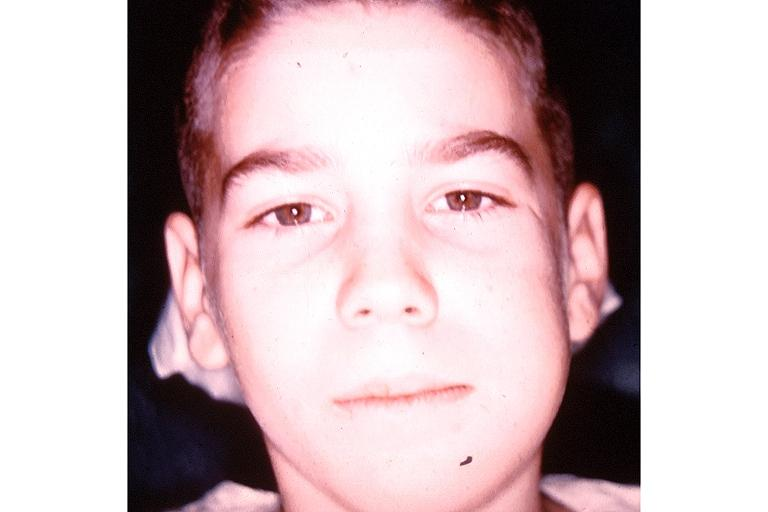does candida in peripheral blood show garres osteomyelitis proliferative periosteitis?
Answer the question using a single word or phrase. No 